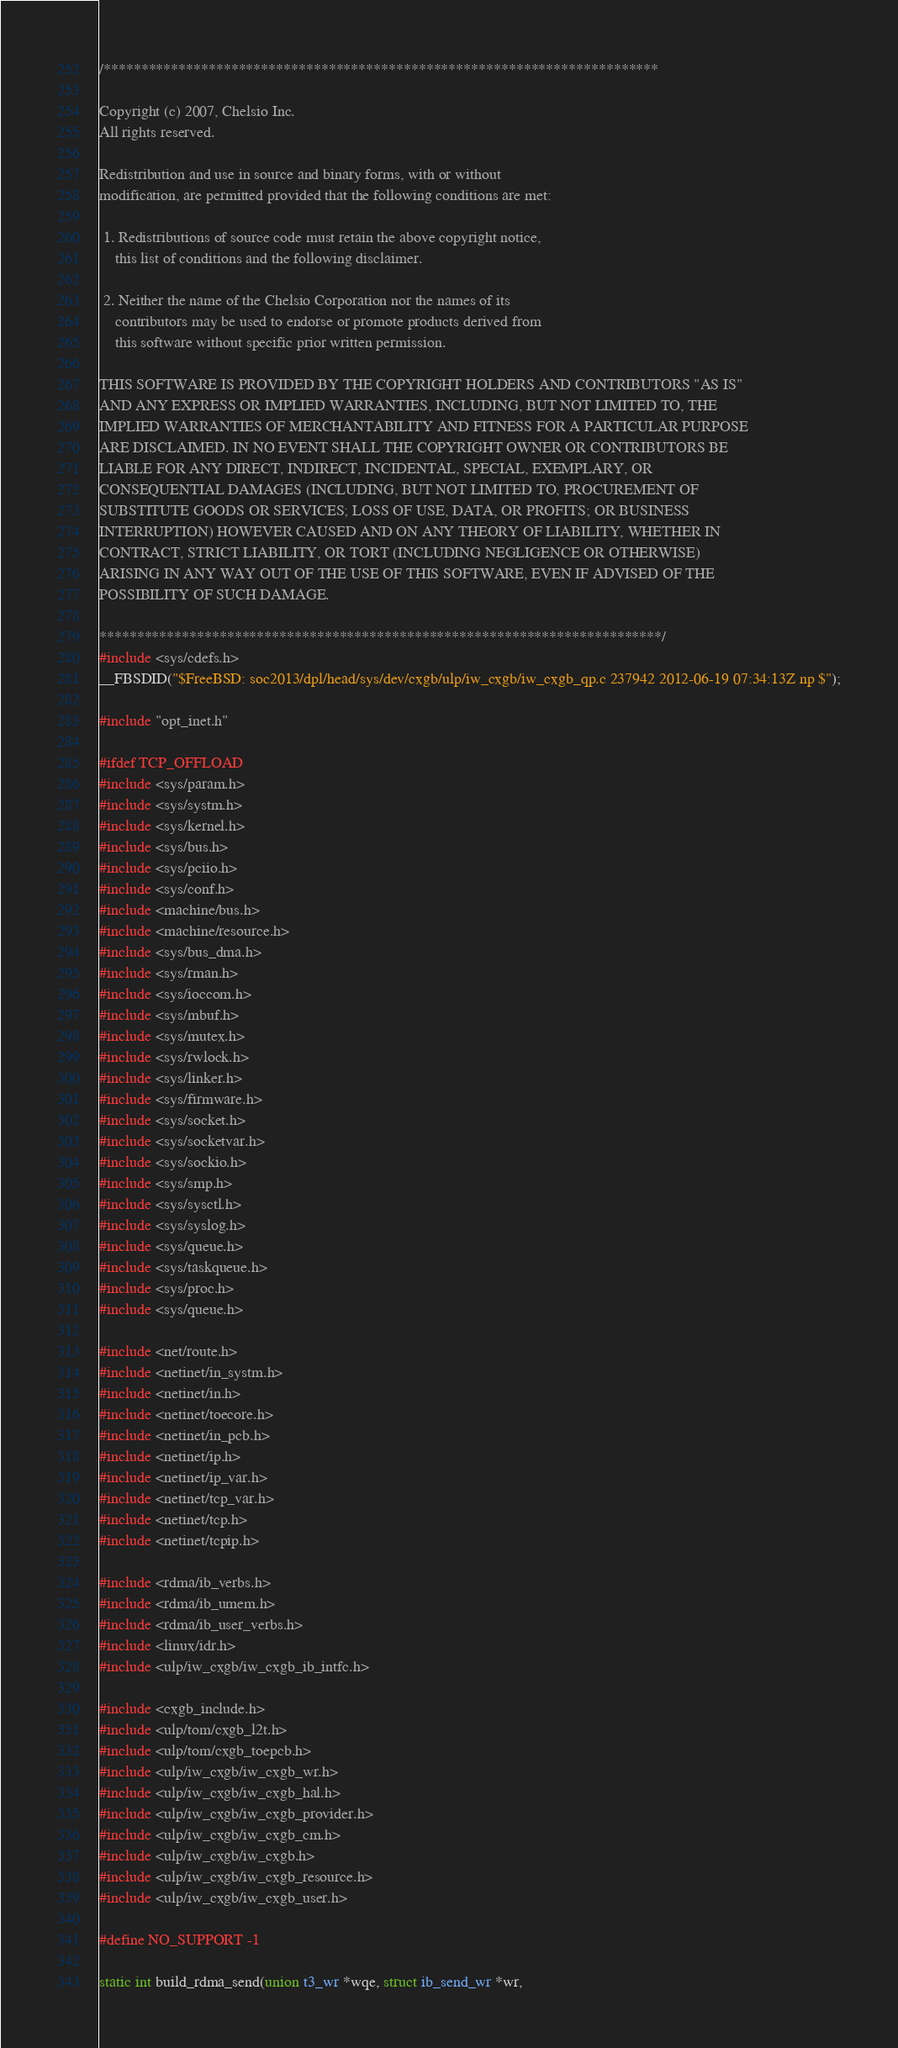<code> <loc_0><loc_0><loc_500><loc_500><_C_>/**************************************************************************

Copyright (c) 2007, Chelsio Inc.
All rights reserved.

Redistribution and use in source and binary forms, with or without
modification, are permitted provided that the following conditions are met:

 1. Redistributions of source code must retain the above copyright notice,
    this list of conditions and the following disclaimer.

 2. Neither the name of the Chelsio Corporation nor the names of its
    contributors may be used to endorse or promote products derived from
    this software without specific prior written permission.

THIS SOFTWARE IS PROVIDED BY THE COPYRIGHT HOLDERS AND CONTRIBUTORS "AS IS"
AND ANY EXPRESS OR IMPLIED WARRANTIES, INCLUDING, BUT NOT LIMITED TO, THE
IMPLIED WARRANTIES OF MERCHANTABILITY AND FITNESS FOR A PARTICULAR PURPOSE
ARE DISCLAIMED. IN NO EVENT SHALL THE COPYRIGHT OWNER OR CONTRIBUTORS BE
LIABLE FOR ANY DIRECT, INDIRECT, INCIDENTAL, SPECIAL, EXEMPLARY, OR
CONSEQUENTIAL DAMAGES (INCLUDING, BUT NOT LIMITED TO, PROCUREMENT OF
SUBSTITUTE GOODS OR SERVICES; LOSS OF USE, DATA, OR PROFITS; OR BUSINESS
INTERRUPTION) HOWEVER CAUSED AND ON ANY THEORY OF LIABILITY, WHETHER IN
CONTRACT, STRICT LIABILITY, OR TORT (INCLUDING NEGLIGENCE OR OTHERWISE)
ARISING IN ANY WAY OUT OF THE USE OF THIS SOFTWARE, EVEN IF ADVISED OF THE
POSSIBILITY OF SUCH DAMAGE.

***************************************************************************/
#include <sys/cdefs.h>
__FBSDID("$FreeBSD: soc2013/dpl/head/sys/dev/cxgb/ulp/iw_cxgb/iw_cxgb_qp.c 237942 2012-06-19 07:34:13Z np $");

#include "opt_inet.h"

#ifdef TCP_OFFLOAD
#include <sys/param.h>
#include <sys/systm.h>
#include <sys/kernel.h>
#include <sys/bus.h>
#include <sys/pciio.h>
#include <sys/conf.h>
#include <machine/bus.h>
#include <machine/resource.h>
#include <sys/bus_dma.h>
#include <sys/rman.h>
#include <sys/ioccom.h>
#include <sys/mbuf.h>
#include <sys/mutex.h>
#include <sys/rwlock.h>
#include <sys/linker.h>
#include <sys/firmware.h>
#include <sys/socket.h>
#include <sys/socketvar.h>
#include <sys/sockio.h>
#include <sys/smp.h>
#include <sys/sysctl.h>
#include <sys/syslog.h>
#include <sys/queue.h>
#include <sys/taskqueue.h>
#include <sys/proc.h>
#include <sys/queue.h>

#include <net/route.h>
#include <netinet/in_systm.h>
#include <netinet/in.h>
#include <netinet/toecore.h>
#include <netinet/in_pcb.h>
#include <netinet/ip.h>
#include <netinet/ip_var.h>
#include <netinet/tcp_var.h>
#include <netinet/tcp.h>
#include <netinet/tcpip.h>

#include <rdma/ib_verbs.h>
#include <rdma/ib_umem.h>
#include <rdma/ib_user_verbs.h>
#include <linux/idr.h>
#include <ulp/iw_cxgb/iw_cxgb_ib_intfc.h>

#include <cxgb_include.h>
#include <ulp/tom/cxgb_l2t.h>
#include <ulp/tom/cxgb_toepcb.h>
#include <ulp/iw_cxgb/iw_cxgb_wr.h>
#include <ulp/iw_cxgb/iw_cxgb_hal.h>
#include <ulp/iw_cxgb/iw_cxgb_provider.h>
#include <ulp/iw_cxgb/iw_cxgb_cm.h>
#include <ulp/iw_cxgb/iw_cxgb.h>
#include <ulp/iw_cxgb/iw_cxgb_resource.h>
#include <ulp/iw_cxgb/iw_cxgb_user.h>

#define NO_SUPPORT -1

static int build_rdma_send(union t3_wr *wqe, struct ib_send_wr *wr,</code> 